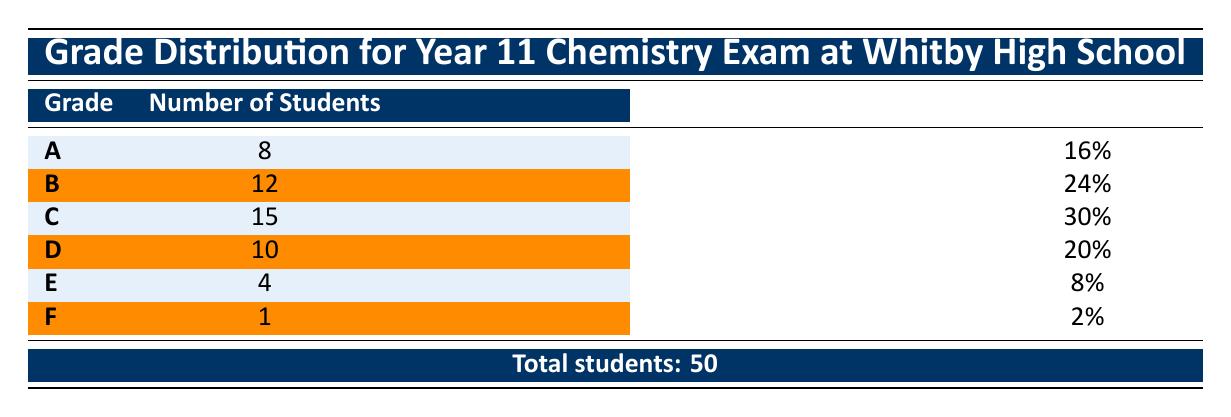What is the grade with the highest number of students? The highest number of students is found under the grade row with the most significant count. Looking through the table, grade C has 15 students, which is more than any other grade listed.
Answer: C How many students received a grade of E or F? To find the total number of students who received a grade of E or F, we add the number of students in the E row (4) to those in the F row (1): 4 + 1 = 5.
Answer: 5 What percentage of students achieved a grade B? The table lists the grade B percentage directly in the corresponding row, which is given as 24%.
Answer: 24% Is it true that more than 50% of students received grades A, B, or C combined? To check if more than 50% of students received grades A, B, or C, we combine their percentages: A (16%) + B (24%) + C (30%) = 70%. Since 70% is greater than 50%, this statement is true.
Answer: Yes What is the average percentage of all grades? First, we list the percentage of each grade: A (16%), B (24%), C (30%), D (20%), E (8%), F (2%). We can sum them up: 16 + 24 + 30 + 20 + 8 + 2 = 100. Since there are 6 grades, we find the average by dividing the total percentage by the number of grades: 100 / 6 = approximately 16.67%.
Answer: 16.67% 